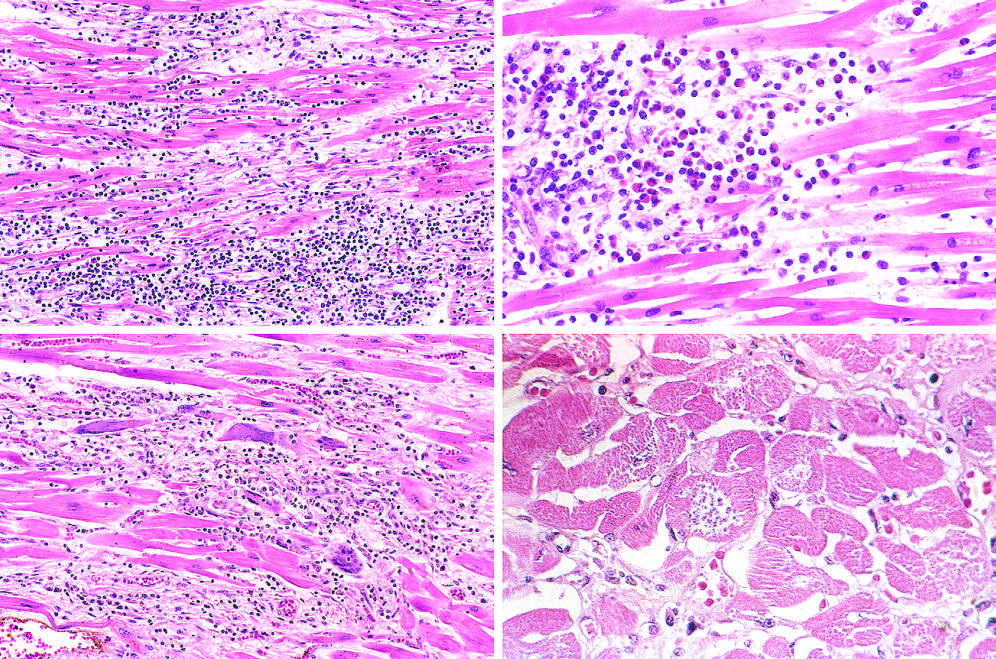re necrotic cells present, along with mononuclear inflammation and myofiber necrosis?
Answer the question using a single word or phrase. No 